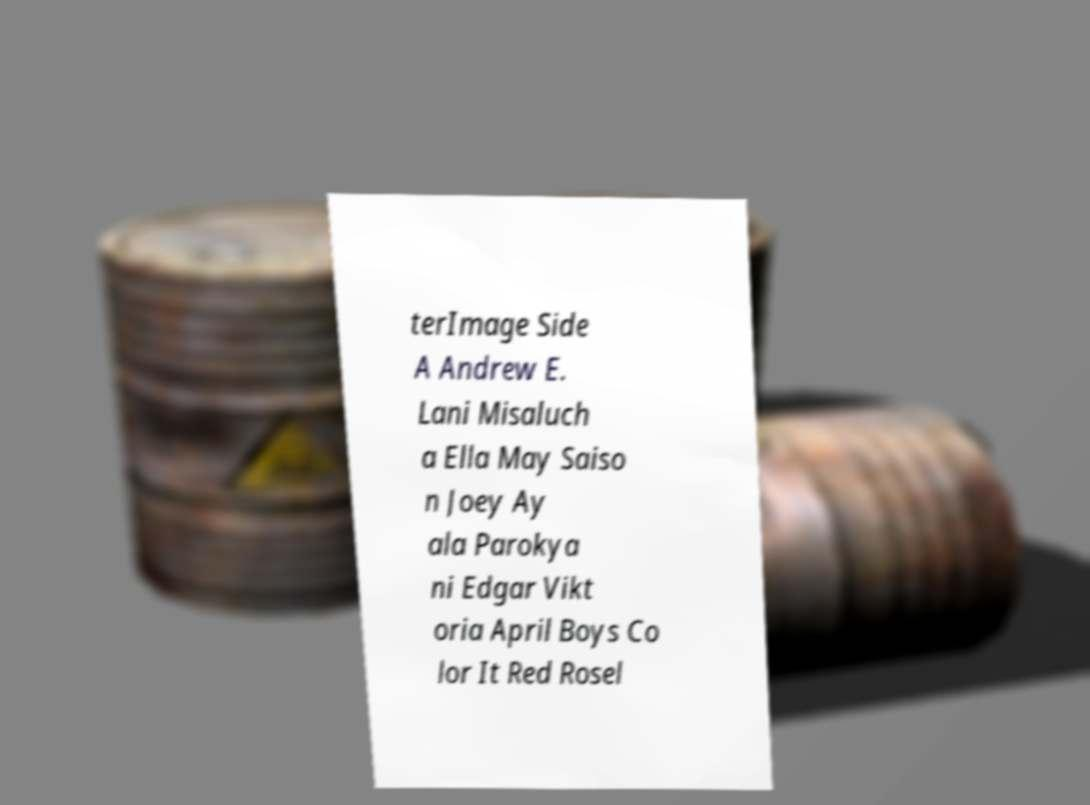There's text embedded in this image that I need extracted. Can you transcribe it verbatim? terImage Side A Andrew E. Lani Misaluch a Ella May Saiso n Joey Ay ala Parokya ni Edgar Vikt oria April Boys Co lor It Red Rosel 